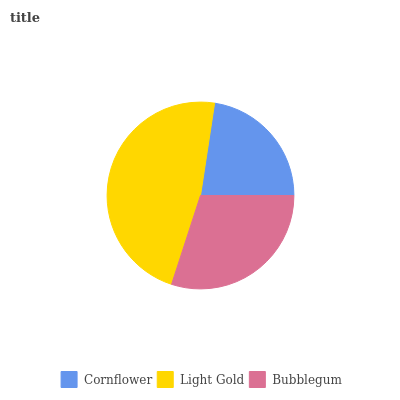Is Cornflower the minimum?
Answer yes or no. Yes. Is Light Gold the maximum?
Answer yes or no. Yes. Is Bubblegum the minimum?
Answer yes or no. No. Is Bubblegum the maximum?
Answer yes or no. No. Is Light Gold greater than Bubblegum?
Answer yes or no. Yes. Is Bubblegum less than Light Gold?
Answer yes or no. Yes. Is Bubblegum greater than Light Gold?
Answer yes or no. No. Is Light Gold less than Bubblegum?
Answer yes or no. No. Is Bubblegum the high median?
Answer yes or no. Yes. Is Bubblegum the low median?
Answer yes or no. Yes. Is Light Gold the high median?
Answer yes or no. No. Is Light Gold the low median?
Answer yes or no. No. 